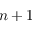Convert formula to latex. <formula><loc_0><loc_0><loc_500><loc_500>n + 1</formula> 